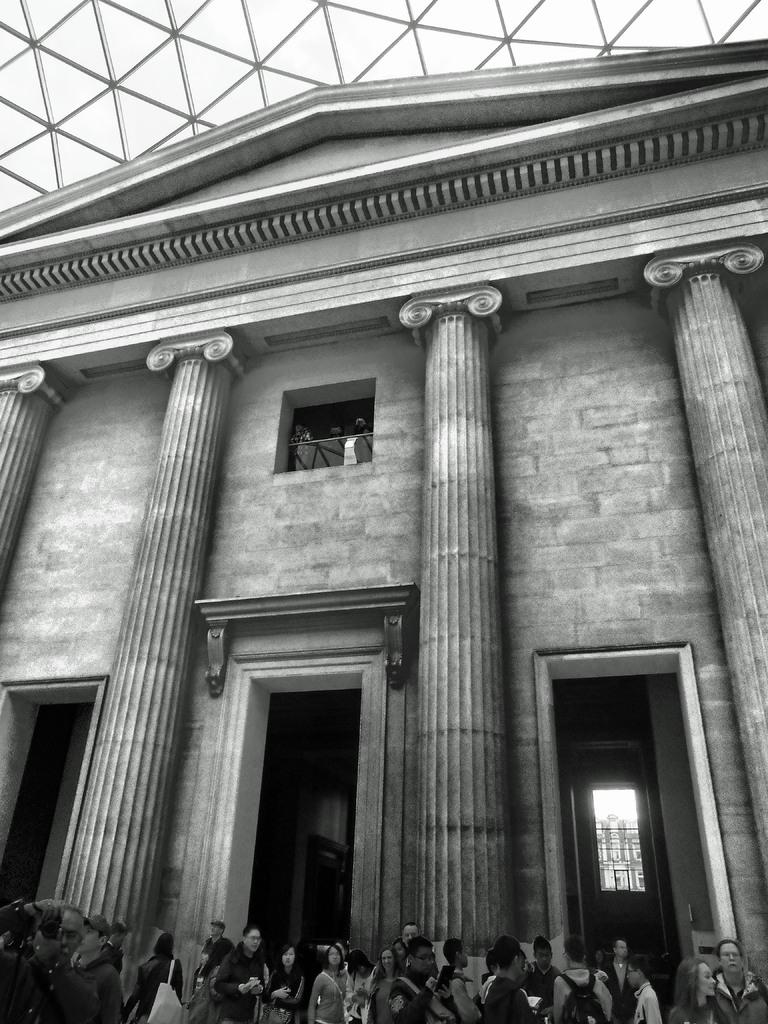What is the color scheme of the image? The image is black and white. What can be seen at the bottom of the image? There are people at the bottom of the image. What type of structure is visible in the background of the image? There is a building in the background of the image. What feature is present in the background of the image? There is a glass roof in the background of the image. What else can be seen in the background of the image? There are objects visible in the background of the image. How many points are visible in the image? There are no points visible in the image. 